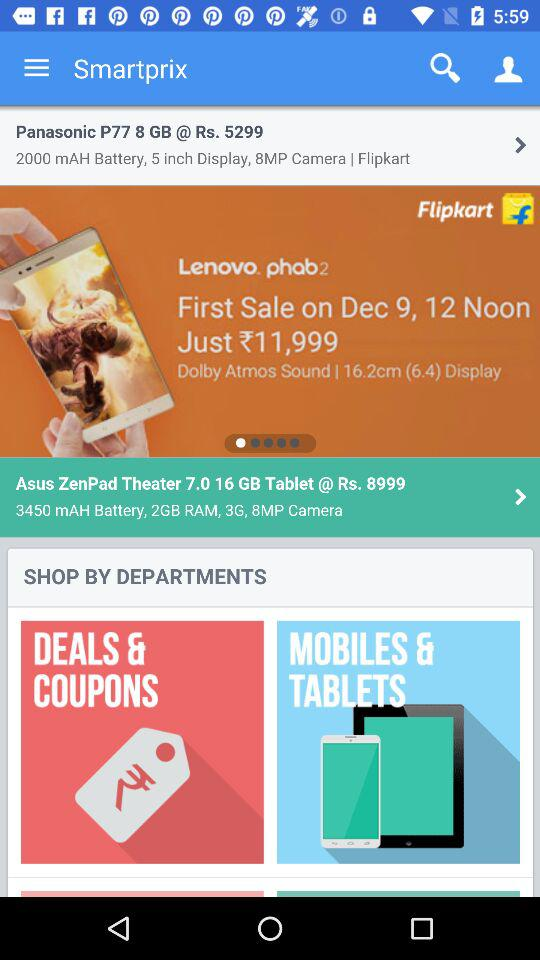What is the price of the "Lenovo Phab2"? The price of the "Lenovo Phab2" is ₹11,999. 